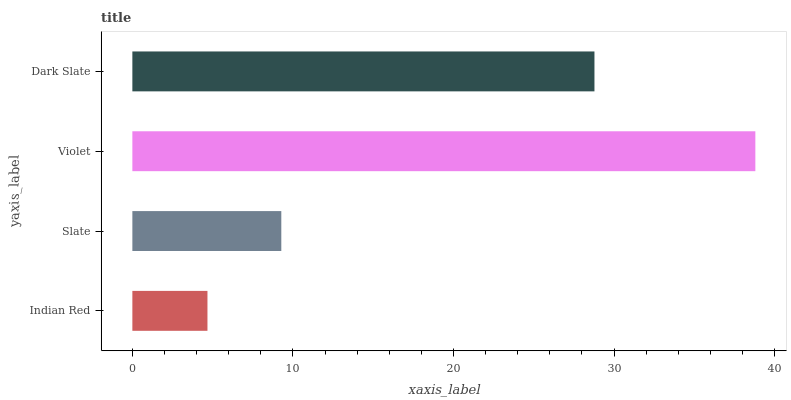Is Indian Red the minimum?
Answer yes or no. Yes. Is Violet the maximum?
Answer yes or no. Yes. Is Slate the minimum?
Answer yes or no. No. Is Slate the maximum?
Answer yes or no. No. Is Slate greater than Indian Red?
Answer yes or no. Yes. Is Indian Red less than Slate?
Answer yes or no. Yes. Is Indian Red greater than Slate?
Answer yes or no. No. Is Slate less than Indian Red?
Answer yes or no. No. Is Dark Slate the high median?
Answer yes or no. Yes. Is Slate the low median?
Answer yes or no. Yes. Is Indian Red the high median?
Answer yes or no. No. Is Dark Slate the low median?
Answer yes or no. No. 